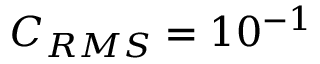Convert formula to latex. <formula><loc_0><loc_0><loc_500><loc_500>C _ { R M S } = 1 0 ^ { - 1 }</formula> 